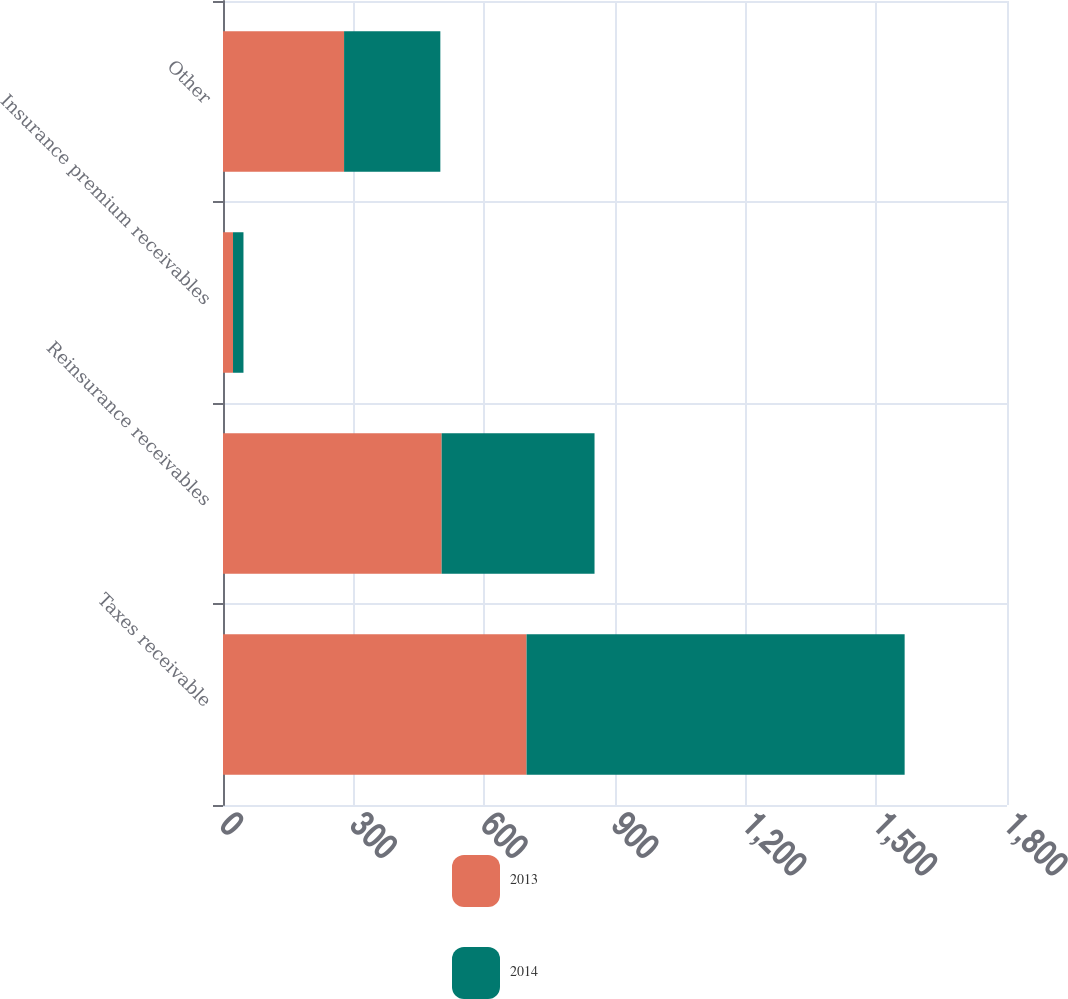Convert chart to OTSL. <chart><loc_0><loc_0><loc_500><loc_500><stacked_bar_chart><ecel><fcel>Taxes receivable<fcel>Reinsurance receivables<fcel>Insurance premium receivables<fcel>Other<nl><fcel>2013<fcel>697<fcel>502<fcel>23<fcel>278<nl><fcel>2014<fcel>868<fcel>351<fcel>24<fcel>221<nl></chart> 